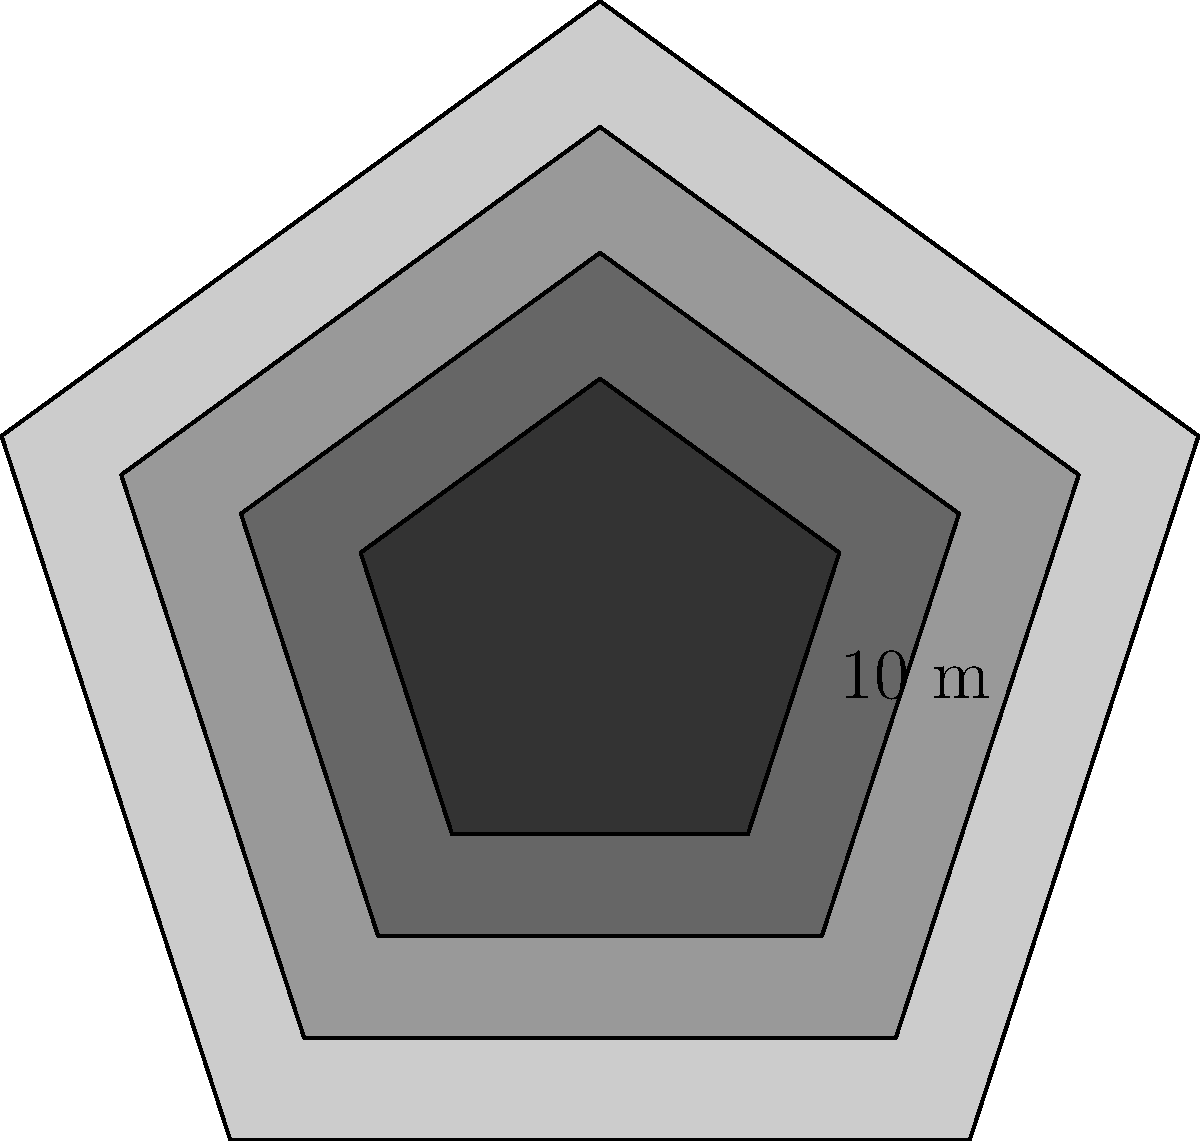A sculptural installation representing layers of identity consists of four stacked regular pentagons, each smaller than the one beneath it. The base pentagon has a side length of 10 meters, and each subsequent layer is scaled down by a factor of 0.8. Calculate the total surface area of the installation, including the top and bottom surfaces. Let's approach this step-by-step:

1) First, we need to calculate the area of each pentagon. The formula for the area of a regular pentagon is:

   $A = \frac{1}{4}\sqrt{25+10\sqrt{5}}s^2$

   Where $s$ is the side length.

2) For the base pentagon (Layer 0):
   $s_0 = 10$ m
   $A_0 = \frac{1}{4}\sqrt{25+10\sqrt{5}}(10)^2 = 172.05$ m²

3) For Layer 1:
   $s_1 = 10 * 0.8 = 8$ m
   $A_1 = \frac{1}{4}\sqrt{25+10\sqrt{5}}(8)^2 = 110.11$ m²

4) For Layer 2:
   $s_2 = 10 * 0.8^2 = 6.4$ m
   $A_2 = \frac{1}{4}\sqrt{25+10\sqrt{5}}(6.4)^2 = 70.47$ m²

5) For Layer 3:
   $s_3 = 10 * 0.8^3 = 5.12$ m
   $A_3 = \frac{1}{4}\sqrt{25+10\sqrt{5}}(5.12)^2 = 45.10$ m²

6) The total surface area includes:
   - The bottom surface (Layer 0)
   - The top surface (Layer 3)
   - The exposed parts of Layers 0, 1, and 2

7) Total surface area:
   $SA_{total} = A_0 + A_3 + (A_0 - A_1) + (A_1 - A_2) + (A_2 - A_3)$
   $SA_{total} = 172.05 + 45.10 + (172.05 - 110.11) + (110.11 - 70.47) + (70.47 - 45.10)$
   $SA_{total} = 344.10$ m²
Answer: 344.10 m² 